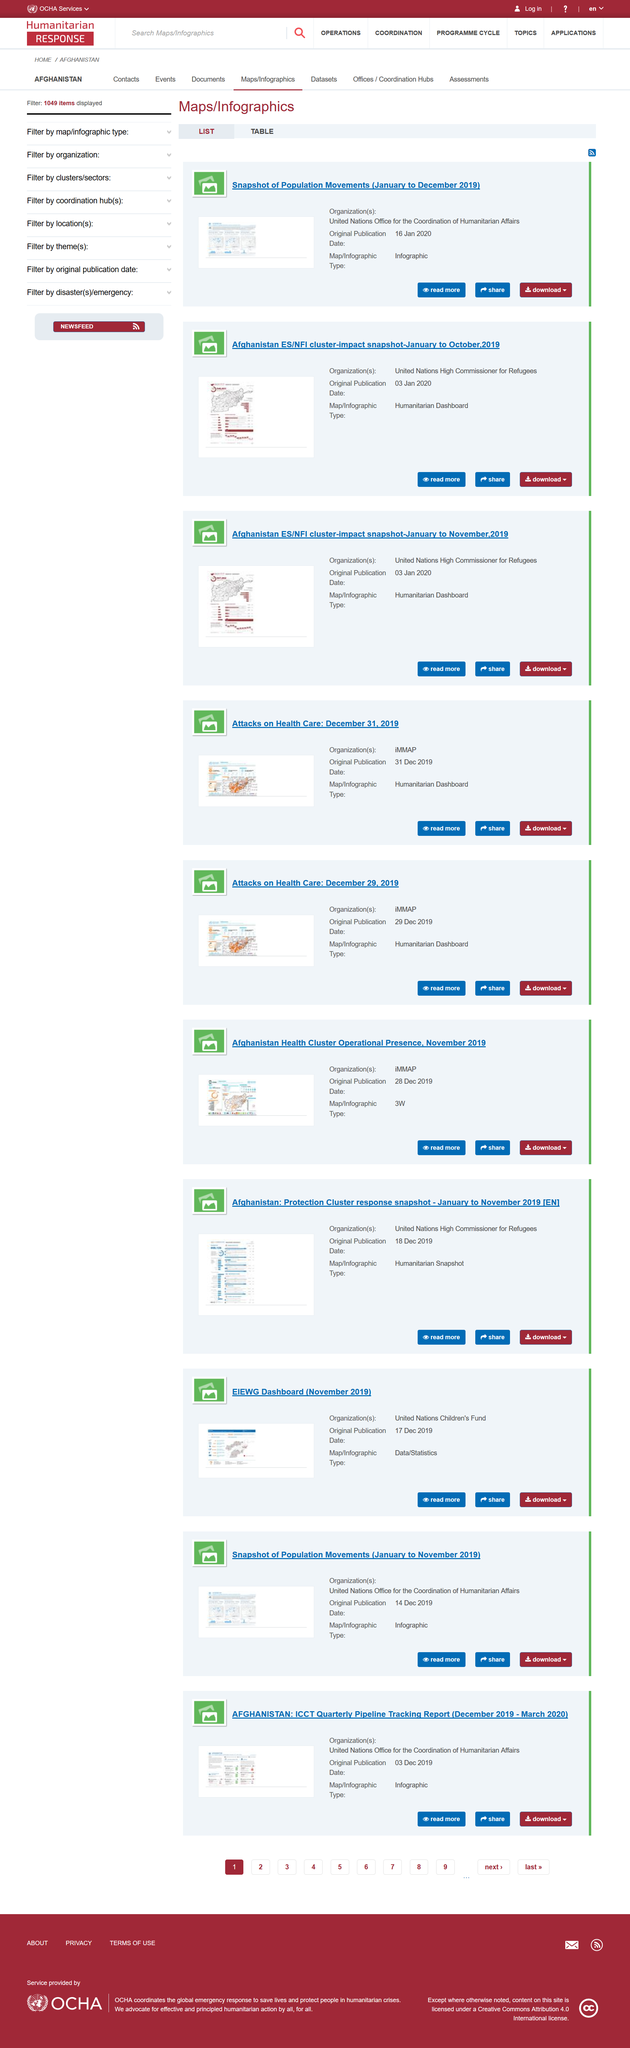Outline some significant characteristics in this image. The snapshot of population movements from January to December 2019 is a detailed infographic that provides a comprehensive overview of the migration patterns and trends in that year. The United Nations Office for the Coordination of Humanitarian Affairs is responsible for taking a snapshot of population movements from January to December 2019. The "Afghanistan ES/NFI cluster-impact snapshot of January to October 2019" is a humanitarian dashboard, which is a type of map or infographic that provides a visual representation of data and information related to humanitarian efforts and their impact on a specific region or topic. 